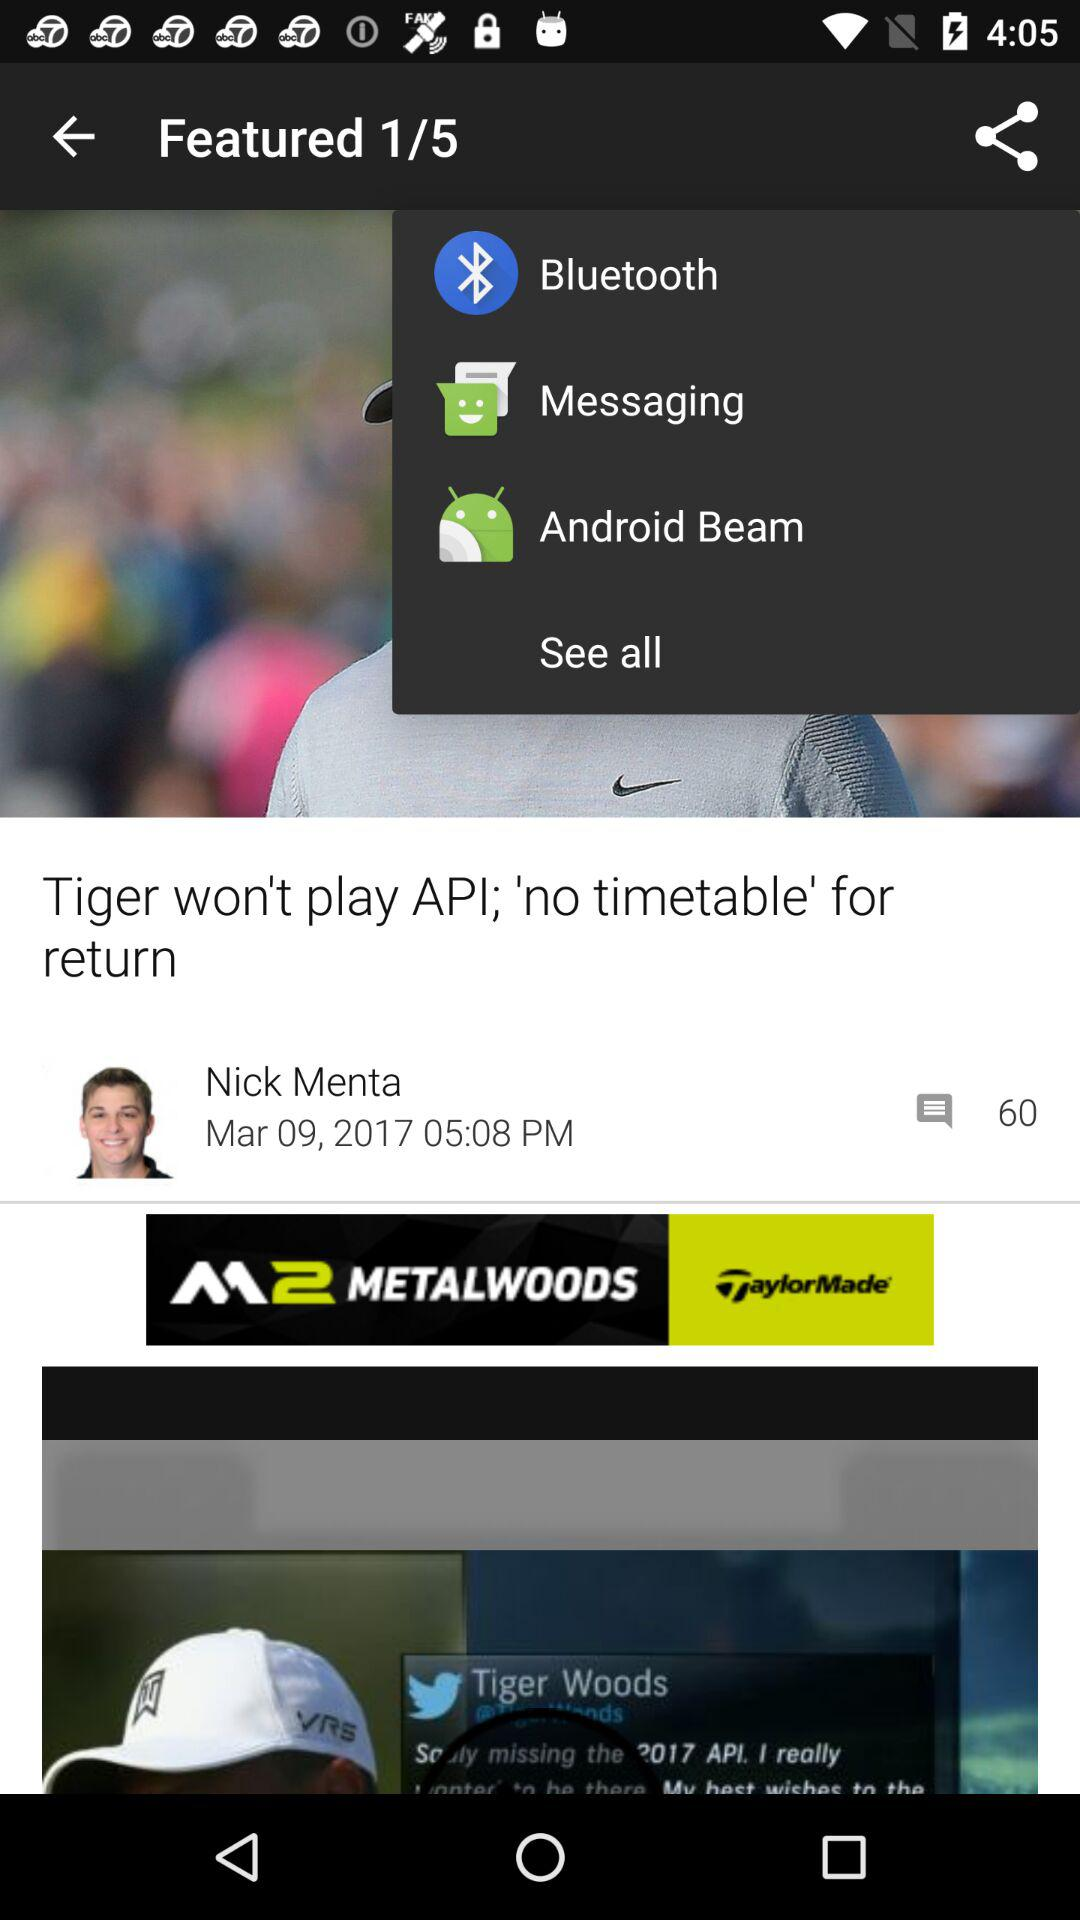How many "Featured" in total are there? There are 5 "Featured". 